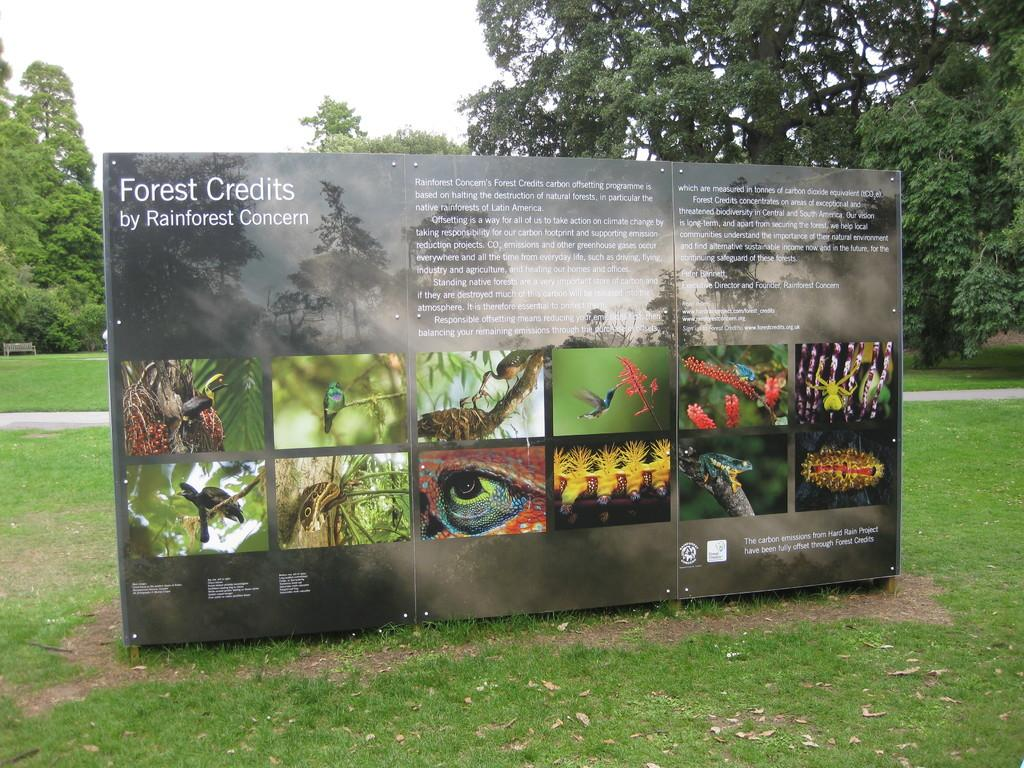What is the main object in the image? There is a board with text and images in the image. Where is the board located? The board is placed on the grass. What can be seen in the background of the image? There are trees in the background of the image. What is visible above the board? The sky is visible in the image. What type of brass instrument is being played in the image? There is no brass instrument or any indication of a musical performance in the image. 